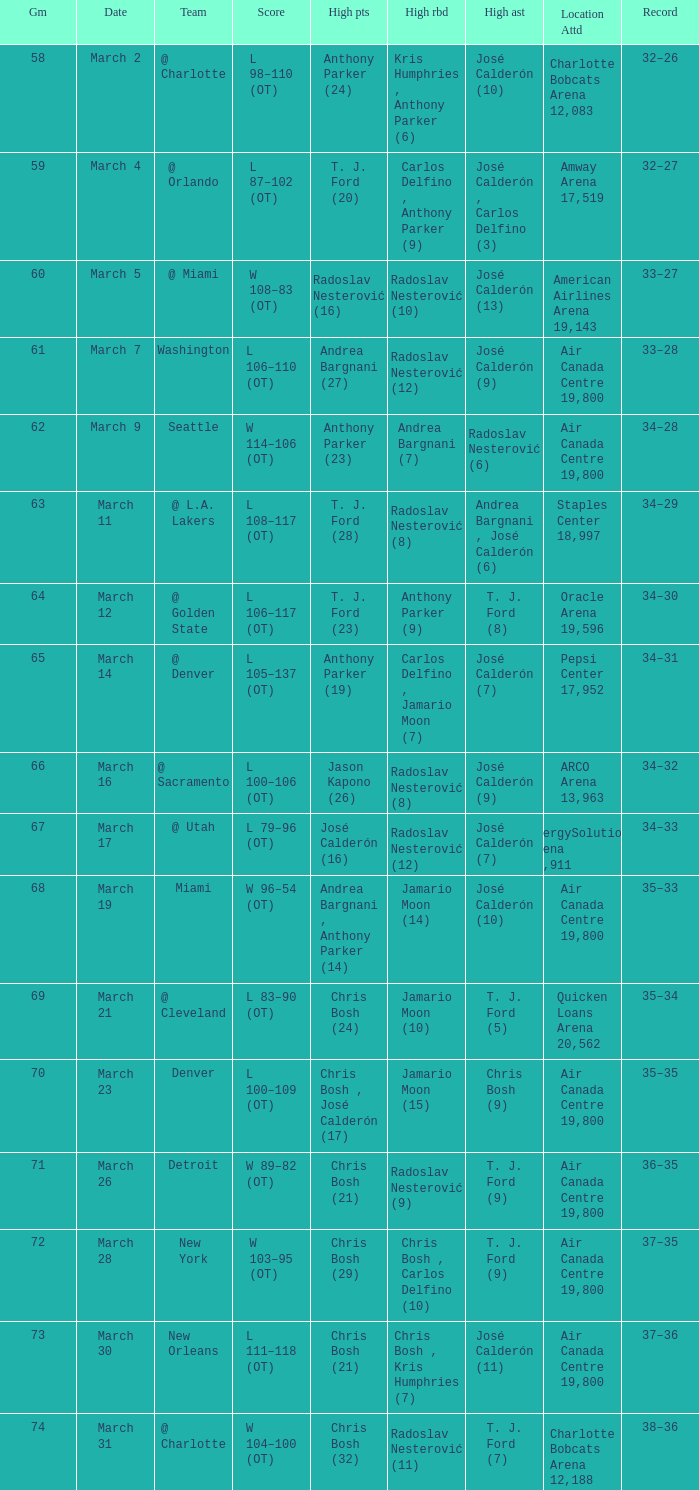How many attended the game on march 16 after over 64 games? ARCO Arena 13,963. 